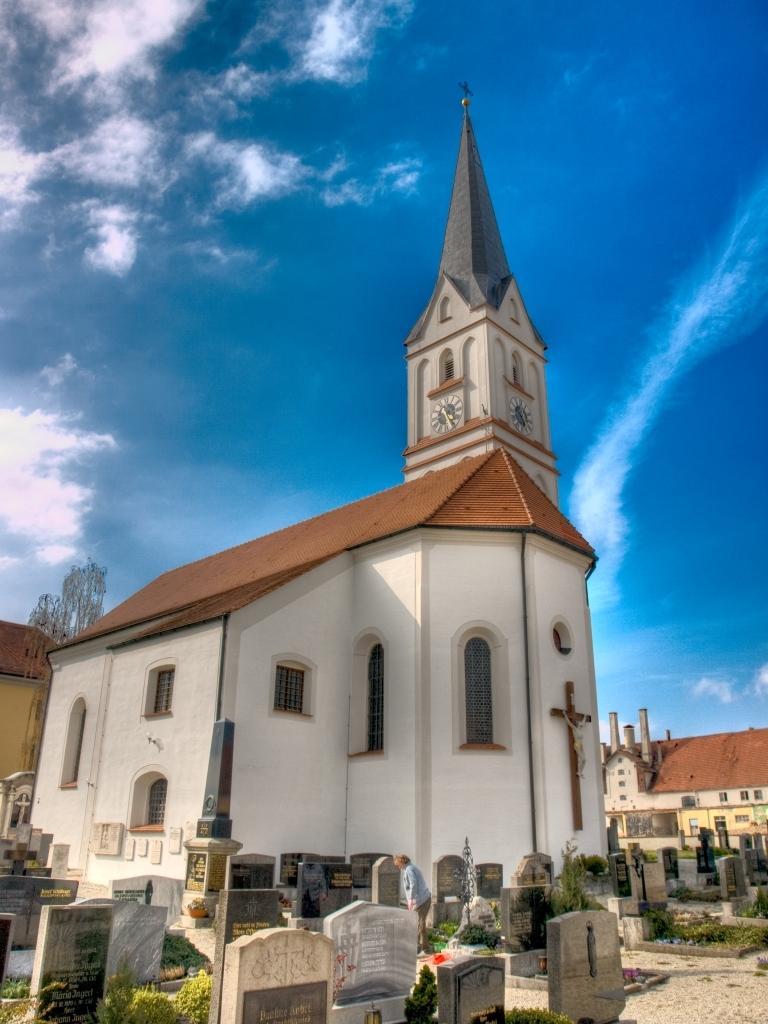How would you summarize this image in a sentence or two? In this picture I see number of tombstones in front and I see few plants. In the background I see number of buildings and I see the sky. 